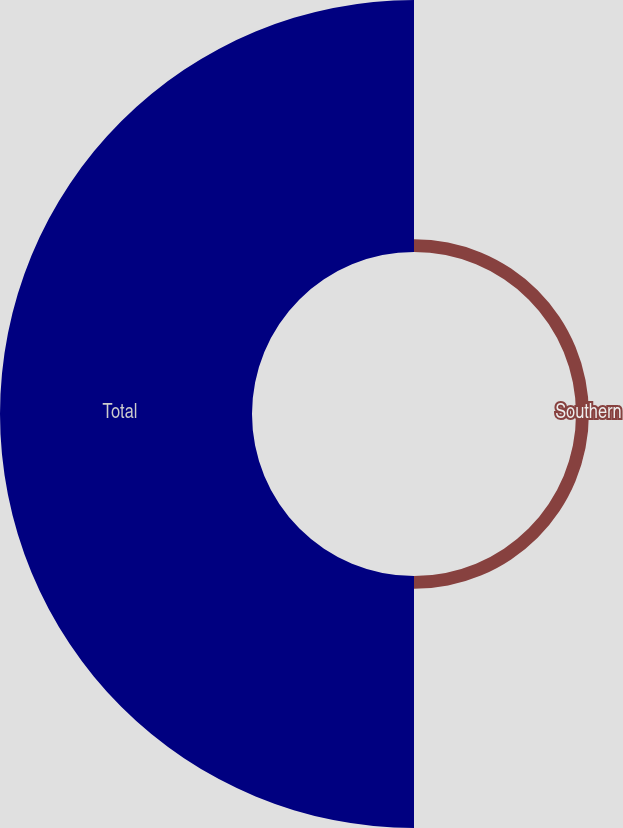<chart> <loc_0><loc_0><loc_500><loc_500><pie_chart><fcel>Southern<fcel>Total<nl><fcel>4.86%<fcel>95.14%<nl></chart> 